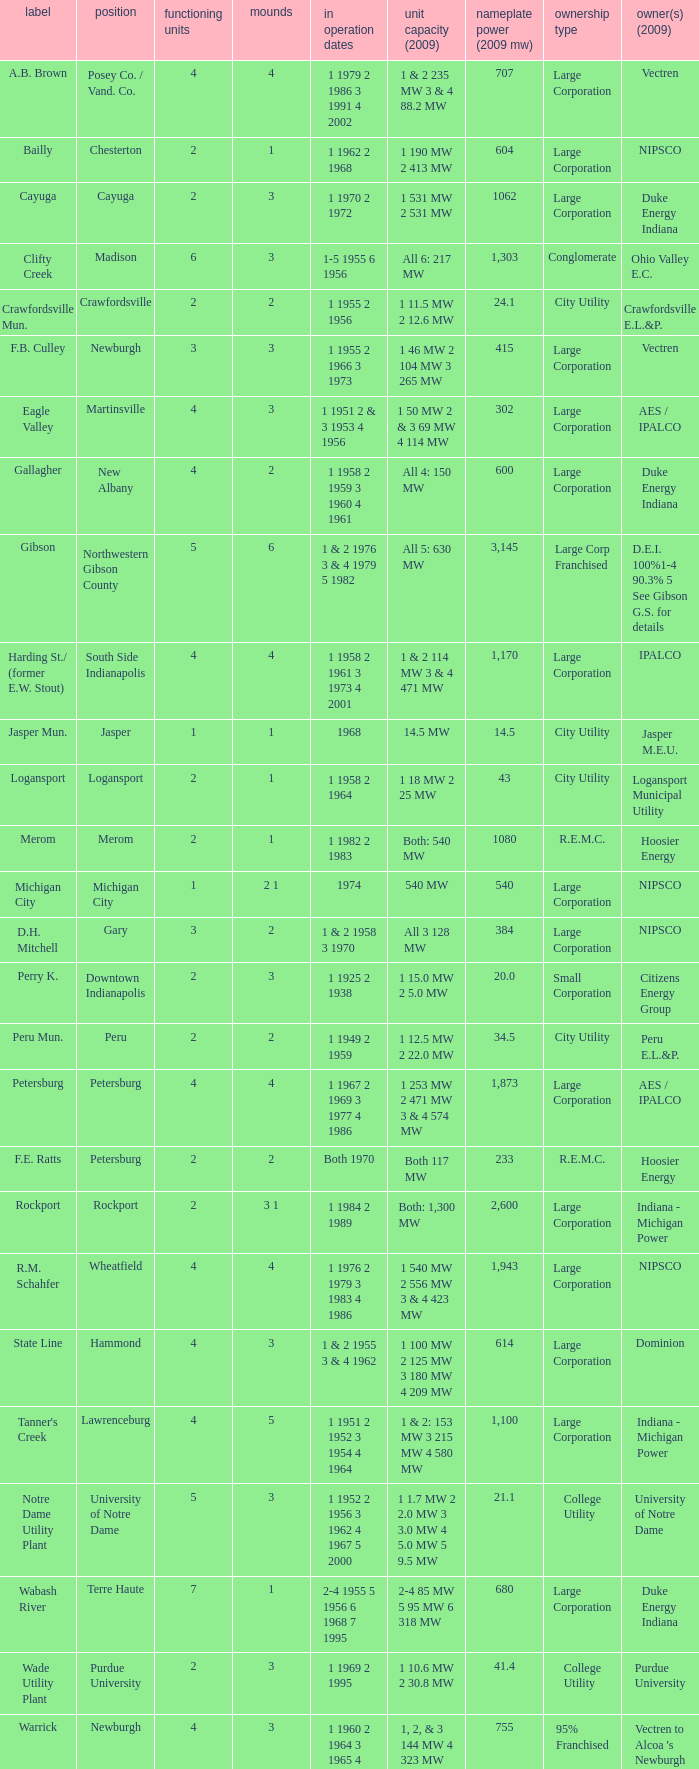Name the owners 2009 for south side indianapolis IPALCO. 